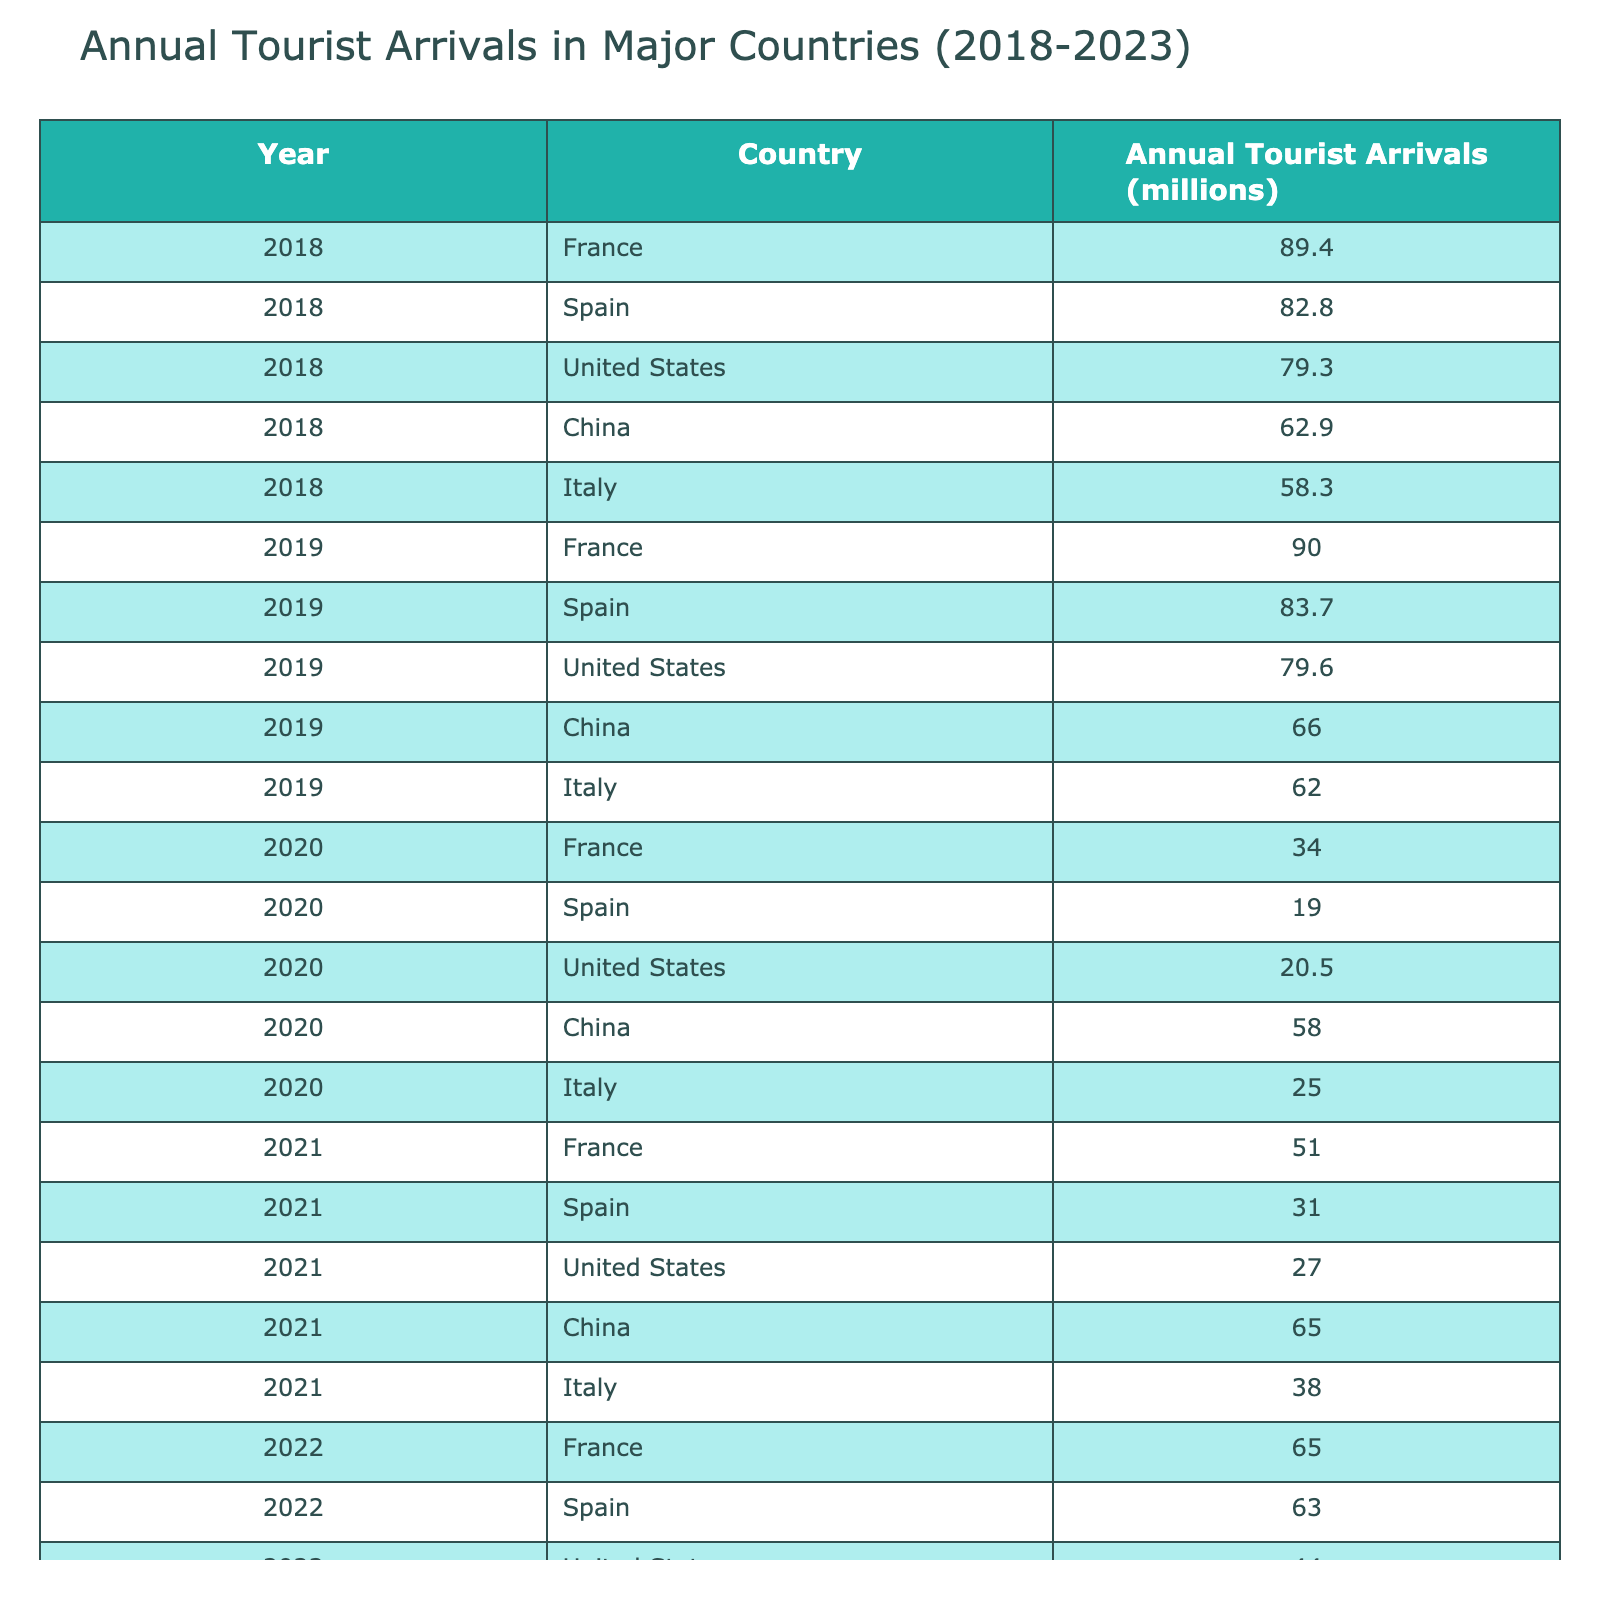What was the annual tourist arrival in France in 2019? According to the table, France had 90.0 million annual tourist arrivals in 2019.
Answer: 90.0 million Which country had the highest number of tourist arrivals in 2022? In 2022, China had the highest annual tourist arrivals with 86.0 million, compared to France, Spain, the United States, and Italy.
Answer: China What is the change in tourist arrivals in Spain from 2018 to 2023? Spain had 82.8 million tourist arrivals in 2018 and 75.5 million in 2023. The change is 75.5 - 82.8 = -7.3 million.
Answer: -7.3 million Calculate the average annual tourist arrivals for the United States from 2018 to 2023. The annual tourist arrivals for the United States are as follows: 79.3 (2018), 79.6 (2019), 20.5 (2020), 27.0 (2021), 44.0 (2022), and 64.0 (2023). Summing these gives 79.3 + 79.6 + 20.5 + 27.0 + 44.0 + 64.0 = 314.4 million. There are 6 years, so the average is 314.4/6 = 52.4 million.
Answer: 52.4 million Did Italy experience a decrease in tourist arrivals from 2019 to 2020? Yes, Italy had 62.0 million tourist arrivals in 2019 and decreased to 25.0 million in 2020, indicating a decrease.
Answer: Yes Which country showed the most significant recovery in tourist arrivals from 2020 to 2023? From 2020 (20.5 million) to 2023 (64.0 million), the United States showed a significant recovery in tourist arrivals, with an increase of 43.5 million.
Answer: United States How many more tourists did China attract than Italy in 2023? In 2023, China had 98.0 million tourist arrivals while Italy had 70.0 million. The difference is 98.0 - 70.0 = 28.0 million.
Answer: 28.0 million Is the percentage increase in tourist arrivals for France from 2020 to 2022 greater than that for Spain during the same period? France increased from 34.0 million in 2020 to 65.0 million in 2022, which is an increase of (65.0 - 34.0)/34.0 * 100 ≈ 91.18%. Spain increased from 19.0 million to 63.0 million, which is an increase of (63.0 - 19.0)/19.0 * 100 ≈ 231.58%. Therefore, Spain had the greater percentage increase.
Answer: No What was the total number of tourist arrivals in the top three countries in 2021? The top three countries in 2021 were France (51.0 million), Spain (31.0 million), and China (65.0 million). The total is 51.0 + 31.0 + 65.0 = 147.0 million.
Answer: 147.0 million How do the tourist arrivals in Italy in 2022 compare to those in 2018? Italy had 58.3 million tourist arrivals in 2018 and 58.0 million in 2022, which indicates that arrivals were slightly lower in 2022 than in 2018.
Answer: Slightly lower 